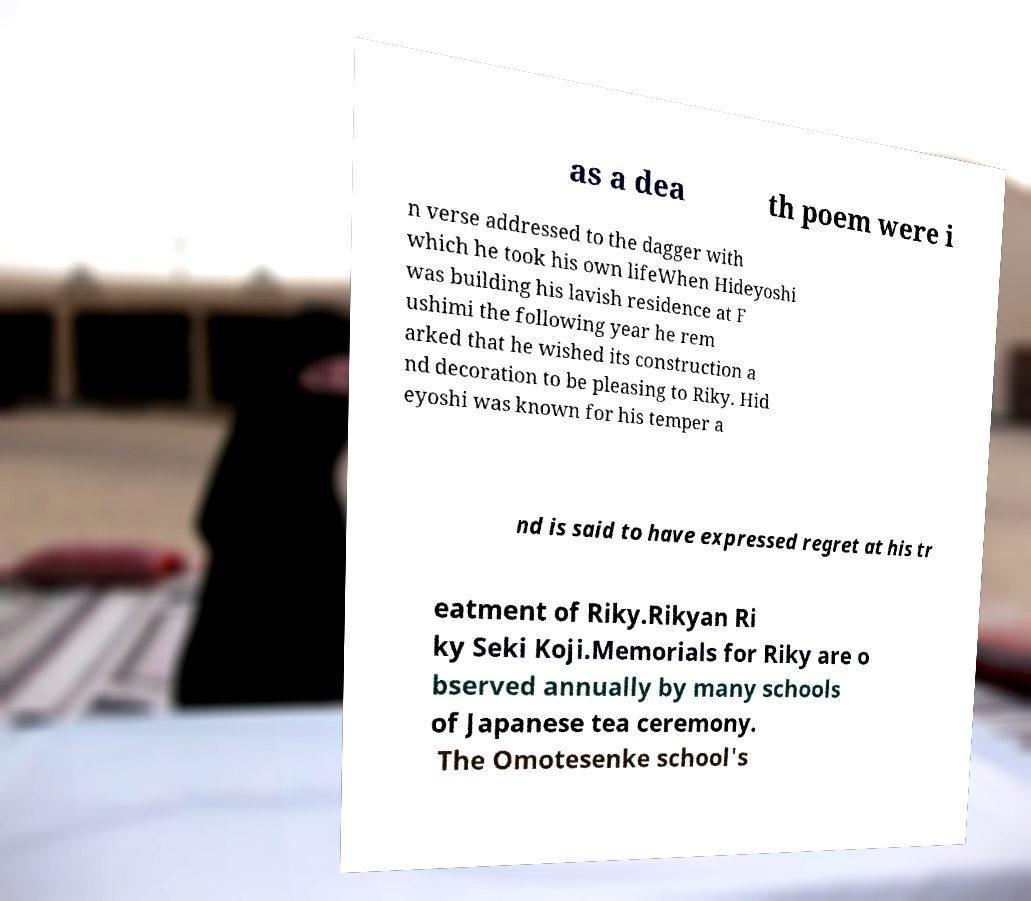Can you accurately transcribe the text from the provided image for me? as a dea th poem were i n verse addressed to the dagger with which he took his own lifeWhen Hideyoshi was building his lavish residence at F ushimi the following year he rem arked that he wished its construction a nd decoration to be pleasing to Riky. Hid eyoshi was known for his temper a nd is said to have expressed regret at his tr eatment of Riky.Rikyan Ri ky Seki Koji.Memorials for Riky are o bserved annually by many schools of Japanese tea ceremony. The Omotesenke school's 